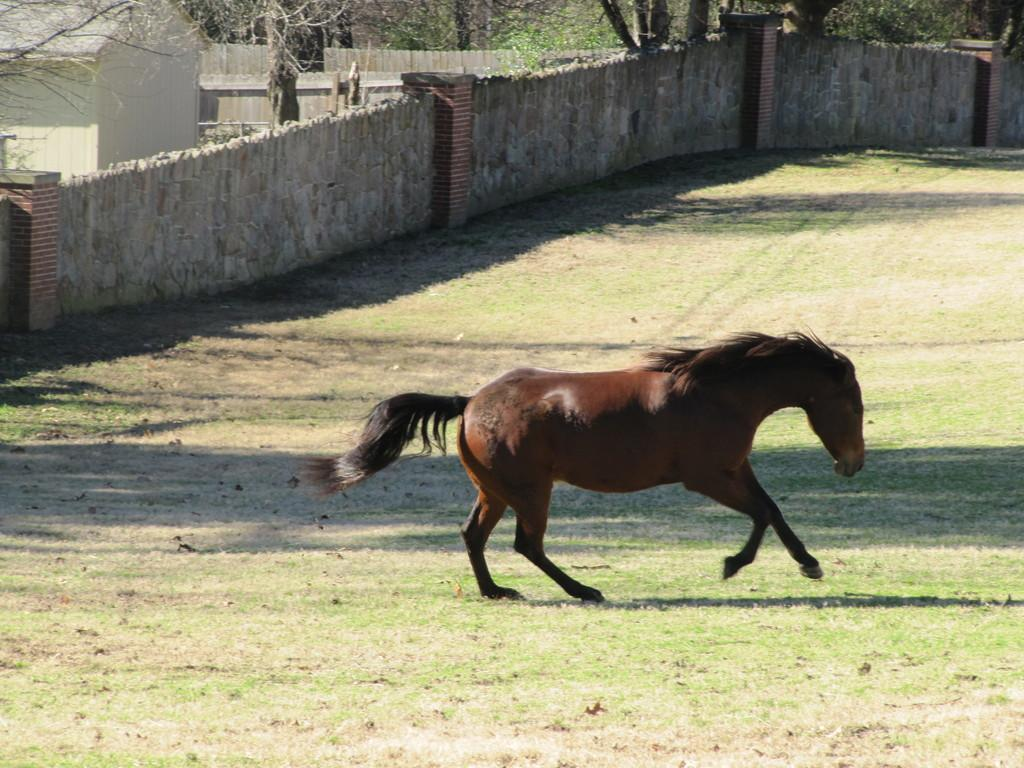What is the horse doing in the image? The horse is running in the image. Where is the horse running? The horse is running on a grassland. What can be seen on the left side of the image? There is a fence wall on the left side of the image. What structures are visible in the background of the image? There is a home and trees present in the background of the image. What type of baseball is the horse holding in the image? There is no baseball present in the image; the horse is running on a grassland. 